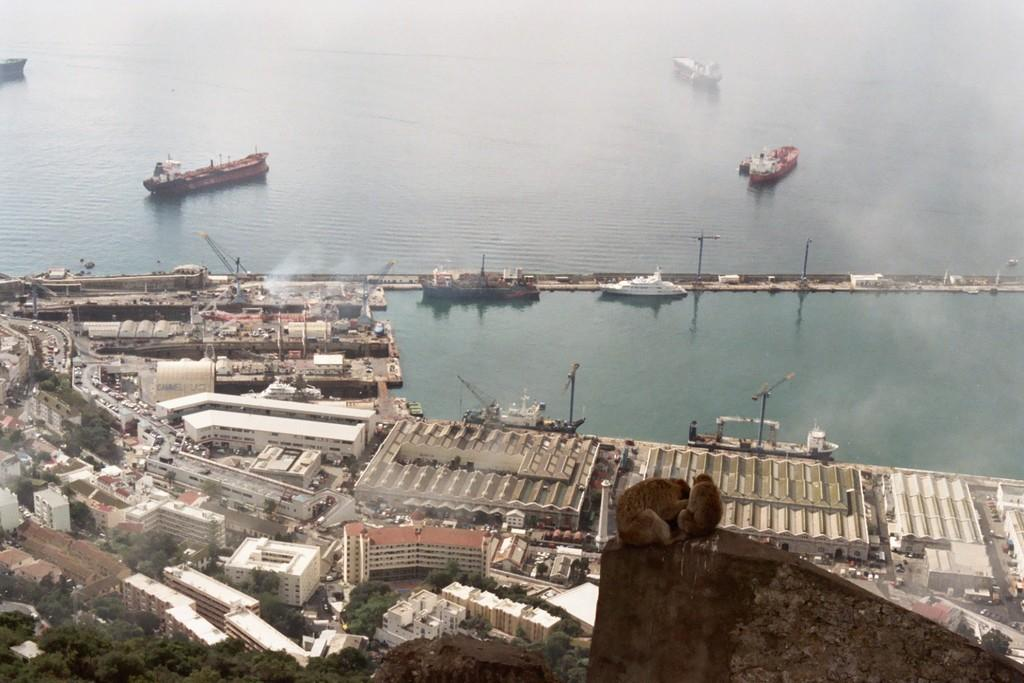What can be seen in the water in the image? There is a group of ships in the water. What structures are visible in the image? There is a group of buildings in the image. What are the poles used for in the image? The purpose of the poles is not specified, but they are visible in the image. What type of vehicles can be seen on the road? There is a group of vehicles on the road. What is the large mechanical structure in the image? There is a crane in the image. What type of vegetation is present in the image? There are trees in the image. What animals are on the surface in the image? There are two monkeys on the surface. What type of bag is hanging from the crane in the image? There is no bag hanging from the crane in the image. Can you see any goats in the image? There are no goats present in the image. 